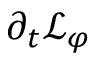<formula> <loc_0><loc_0><loc_500><loc_500>\partial _ { t } \mathcal { L } _ { \varphi }</formula> 